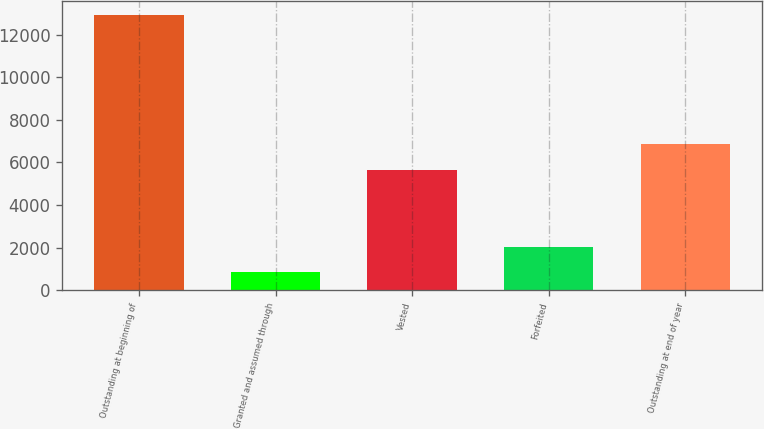Convert chart to OTSL. <chart><loc_0><loc_0><loc_500><loc_500><bar_chart><fcel>Outstanding at beginning of<fcel>Granted and assumed through<fcel>Vested<fcel>Forfeited<fcel>Outstanding at end of year<nl><fcel>12930<fcel>836<fcel>5631<fcel>2045.4<fcel>6864<nl></chart> 